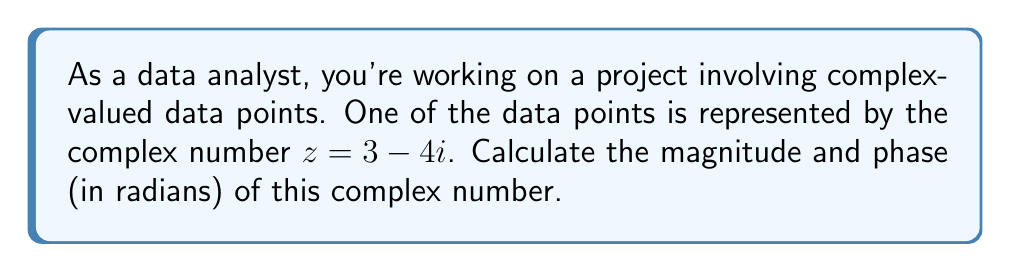Help me with this question. To calculate the magnitude and phase of a complex number $z = a + bi$, we use the following formulas:

1. Magnitude: $|z| = \sqrt{a^2 + b^2}$
2. Phase: $\theta = \arctan2(b, a)$

For $z = 3 - 4i$:

Step 1: Calculate the magnitude
$$|z| = \sqrt{3^2 + (-4)^2} = \sqrt{9 + 16} = \sqrt{25} = 5$$

Step 2: Calculate the phase
$$\theta = \arctan2(-4, 3)$$

Using a calculator or programming function:
$$\theta \approx -0.9272952180016122 \text{ radians}$$

Note: The $\arctan2$ function is used instead of regular $\arctan$ to determine the correct quadrant of the angle.
Answer: Magnitude: 5, Phase: -0.9273 radians 